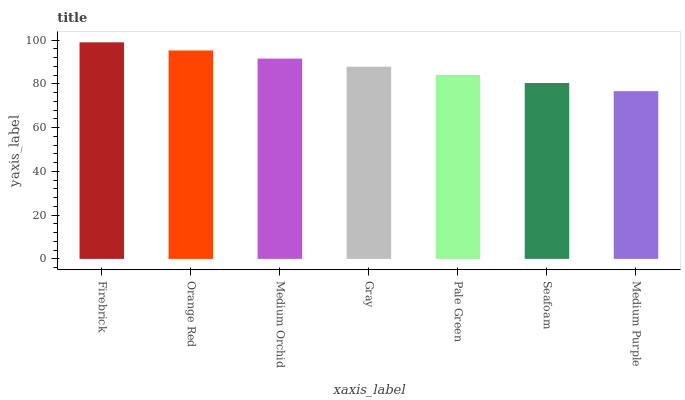Is Medium Purple the minimum?
Answer yes or no. Yes. Is Firebrick the maximum?
Answer yes or no. Yes. Is Orange Red the minimum?
Answer yes or no. No. Is Orange Red the maximum?
Answer yes or no. No. Is Firebrick greater than Orange Red?
Answer yes or no. Yes. Is Orange Red less than Firebrick?
Answer yes or no. Yes. Is Orange Red greater than Firebrick?
Answer yes or no. No. Is Firebrick less than Orange Red?
Answer yes or no. No. Is Gray the high median?
Answer yes or no. Yes. Is Gray the low median?
Answer yes or no. Yes. Is Firebrick the high median?
Answer yes or no. No. Is Medium Orchid the low median?
Answer yes or no. No. 